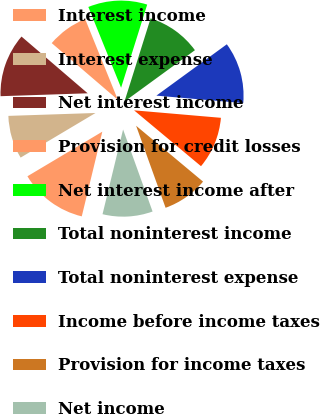Convert chart to OTSL. <chart><loc_0><loc_0><loc_500><loc_500><pie_chart><fcel>Interest income<fcel>Interest expense<fcel>Net interest income<fcel>Provision for credit losses<fcel>Net interest income after<fcel>Total noninterest income<fcel>Total noninterest expense<fcel>Income before income taxes<fcel>Provision for income taxes<fcel>Net income<nl><fcel>12.66%<fcel>8.02%<fcel>11.81%<fcel>7.59%<fcel>10.97%<fcel>10.13%<fcel>11.39%<fcel>9.7%<fcel>8.44%<fcel>9.28%<nl></chart> 